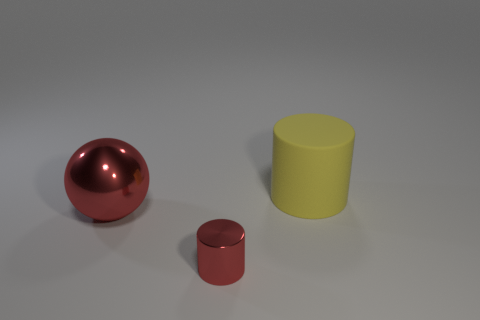The red object to the right of the big thing that is on the left side of the cylinder left of the big matte thing is made of what material? metal 